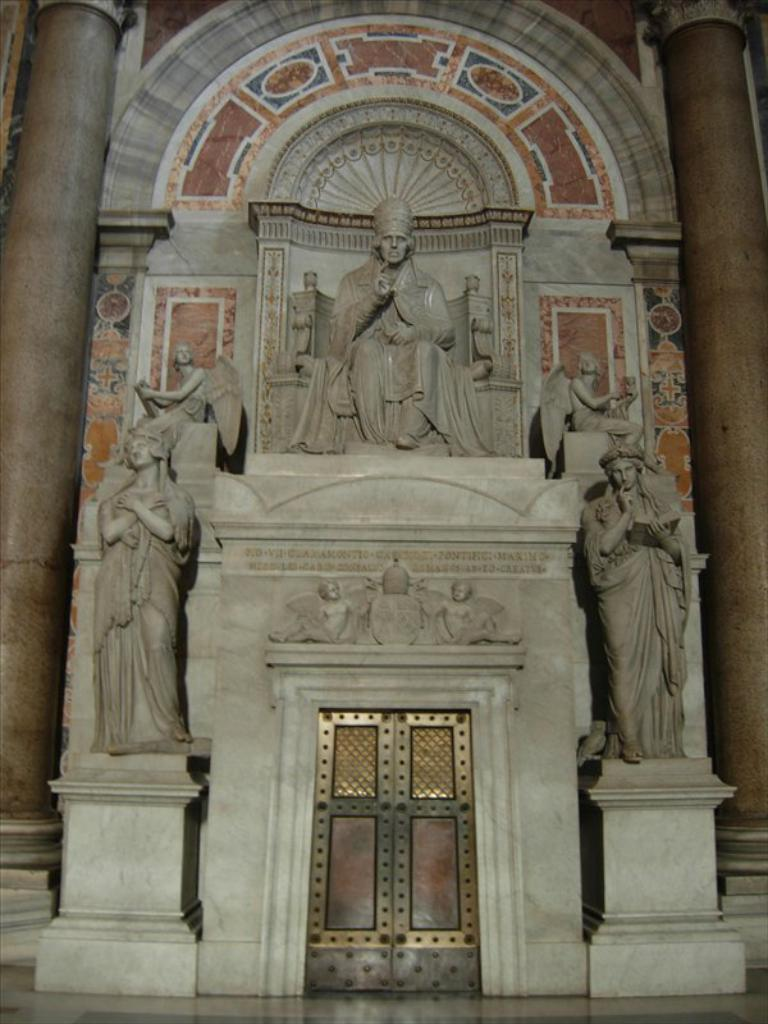What type of location is shown in the image? The image depicts the interior of a building. What artistic elements can be seen in the image? There are multiple sculptures in the image. What architectural feature is present in the image? There is an arch in the image. What material is used for the design in the image? The image features a marble design. In which direction does the horse face in the image? There is no horse present in the image. 